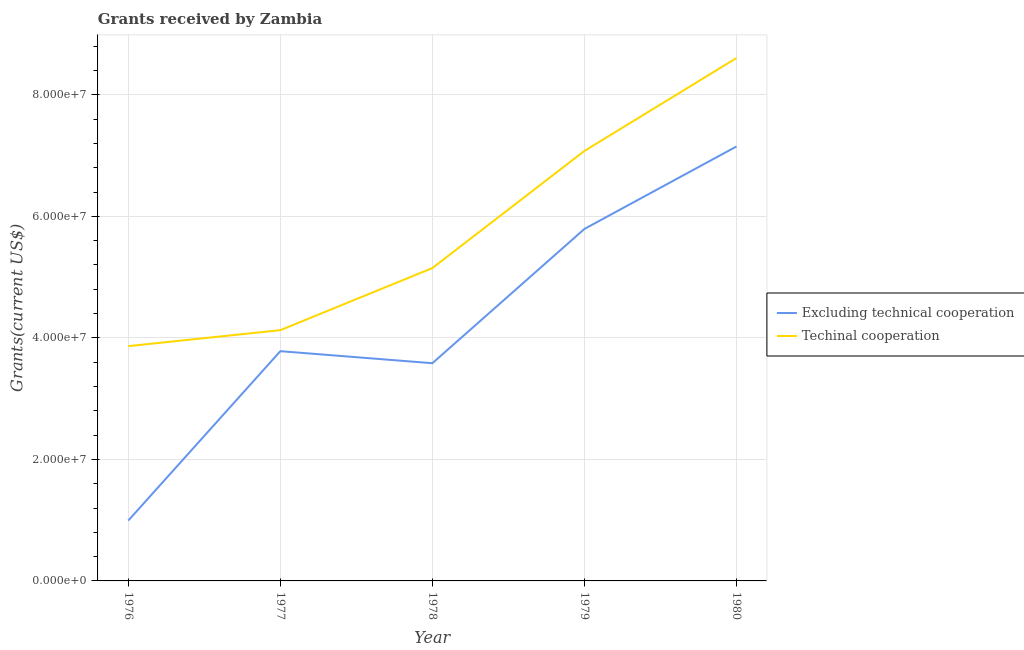Does the line corresponding to amount of grants received(excluding technical cooperation) intersect with the line corresponding to amount of grants received(including technical cooperation)?
Your answer should be very brief. No. What is the amount of grants received(excluding technical cooperation) in 1978?
Keep it short and to the point. 3.58e+07. Across all years, what is the maximum amount of grants received(including technical cooperation)?
Your answer should be compact. 8.61e+07. Across all years, what is the minimum amount of grants received(including technical cooperation)?
Provide a short and direct response. 3.86e+07. In which year was the amount of grants received(including technical cooperation) maximum?
Offer a very short reply. 1980. In which year was the amount of grants received(including technical cooperation) minimum?
Provide a succinct answer. 1976. What is the total amount of grants received(excluding technical cooperation) in the graph?
Your response must be concise. 2.13e+08. What is the difference between the amount of grants received(including technical cooperation) in 1976 and that in 1980?
Make the answer very short. -4.74e+07. What is the difference between the amount of grants received(excluding technical cooperation) in 1979 and the amount of grants received(including technical cooperation) in 1976?
Keep it short and to the point. 1.93e+07. What is the average amount of grants received(including technical cooperation) per year?
Your response must be concise. 5.76e+07. In the year 1979, what is the difference between the amount of grants received(including technical cooperation) and amount of grants received(excluding technical cooperation)?
Offer a terse response. 1.28e+07. In how many years, is the amount of grants received(including technical cooperation) greater than 32000000 US$?
Keep it short and to the point. 5. What is the ratio of the amount of grants received(including technical cooperation) in 1977 to that in 1978?
Offer a very short reply. 0.8. Is the difference between the amount of grants received(excluding technical cooperation) in 1979 and 1980 greater than the difference between the amount of grants received(including technical cooperation) in 1979 and 1980?
Provide a short and direct response. Yes. What is the difference between the highest and the second highest amount of grants received(including technical cooperation)?
Offer a very short reply. 1.53e+07. What is the difference between the highest and the lowest amount of grants received(including technical cooperation)?
Provide a succinct answer. 4.74e+07. Is the amount of grants received(excluding technical cooperation) strictly greater than the amount of grants received(including technical cooperation) over the years?
Ensure brevity in your answer.  No. How many years are there in the graph?
Provide a short and direct response. 5. Are the values on the major ticks of Y-axis written in scientific E-notation?
Ensure brevity in your answer.  Yes. Where does the legend appear in the graph?
Make the answer very short. Center right. What is the title of the graph?
Keep it short and to the point. Grants received by Zambia. Does "Young" appear as one of the legend labels in the graph?
Provide a succinct answer. No. What is the label or title of the X-axis?
Provide a short and direct response. Year. What is the label or title of the Y-axis?
Ensure brevity in your answer.  Grants(current US$). What is the Grants(current US$) in Excluding technical cooperation in 1976?
Offer a very short reply. 9.93e+06. What is the Grants(current US$) in Techinal cooperation in 1976?
Your answer should be compact. 3.86e+07. What is the Grants(current US$) of Excluding technical cooperation in 1977?
Your answer should be compact. 3.78e+07. What is the Grants(current US$) in Techinal cooperation in 1977?
Offer a very short reply. 4.13e+07. What is the Grants(current US$) in Excluding technical cooperation in 1978?
Keep it short and to the point. 3.58e+07. What is the Grants(current US$) of Techinal cooperation in 1978?
Keep it short and to the point. 5.15e+07. What is the Grants(current US$) of Excluding technical cooperation in 1979?
Offer a very short reply. 5.79e+07. What is the Grants(current US$) in Techinal cooperation in 1979?
Offer a very short reply. 7.08e+07. What is the Grants(current US$) in Excluding technical cooperation in 1980?
Offer a terse response. 7.15e+07. What is the Grants(current US$) of Techinal cooperation in 1980?
Offer a terse response. 8.61e+07. Across all years, what is the maximum Grants(current US$) in Excluding technical cooperation?
Offer a very short reply. 7.15e+07. Across all years, what is the maximum Grants(current US$) of Techinal cooperation?
Offer a terse response. 8.61e+07. Across all years, what is the minimum Grants(current US$) of Excluding technical cooperation?
Provide a short and direct response. 9.93e+06. Across all years, what is the minimum Grants(current US$) in Techinal cooperation?
Provide a succinct answer. 3.86e+07. What is the total Grants(current US$) in Excluding technical cooperation in the graph?
Offer a very short reply. 2.13e+08. What is the total Grants(current US$) in Techinal cooperation in the graph?
Your answer should be very brief. 2.88e+08. What is the difference between the Grants(current US$) of Excluding technical cooperation in 1976 and that in 1977?
Your answer should be very brief. -2.79e+07. What is the difference between the Grants(current US$) of Techinal cooperation in 1976 and that in 1977?
Offer a very short reply. -2.63e+06. What is the difference between the Grants(current US$) in Excluding technical cooperation in 1976 and that in 1978?
Make the answer very short. -2.59e+07. What is the difference between the Grants(current US$) in Techinal cooperation in 1976 and that in 1978?
Ensure brevity in your answer.  -1.28e+07. What is the difference between the Grants(current US$) of Excluding technical cooperation in 1976 and that in 1979?
Offer a very short reply. -4.80e+07. What is the difference between the Grants(current US$) of Techinal cooperation in 1976 and that in 1979?
Your answer should be compact. -3.21e+07. What is the difference between the Grants(current US$) of Excluding technical cooperation in 1976 and that in 1980?
Offer a very short reply. -6.16e+07. What is the difference between the Grants(current US$) in Techinal cooperation in 1976 and that in 1980?
Offer a terse response. -4.74e+07. What is the difference between the Grants(current US$) of Excluding technical cooperation in 1977 and that in 1978?
Keep it short and to the point. 1.98e+06. What is the difference between the Grants(current US$) of Techinal cooperation in 1977 and that in 1978?
Make the answer very short. -1.02e+07. What is the difference between the Grants(current US$) of Excluding technical cooperation in 1977 and that in 1979?
Ensure brevity in your answer.  -2.01e+07. What is the difference between the Grants(current US$) of Techinal cooperation in 1977 and that in 1979?
Give a very brief answer. -2.95e+07. What is the difference between the Grants(current US$) in Excluding technical cooperation in 1977 and that in 1980?
Provide a short and direct response. -3.37e+07. What is the difference between the Grants(current US$) of Techinal cooperation in 1977 and that in 1980?
Keep it short and to the point. -4.48e+07. What is the difference between the Grants(current US$) of Excluding technical cooperation in 1978 and that in 1979?
Offer a very short reply. -2.21e+07. What is the difference between the Grants(current US$) of Techinal cooperation in 1978 and that in 1979?
Your answer should be compact. -1.93e+07. What is the difference between the Grants(current US$) in Excluding technical cooperation in 1978 and that in 1980?
Your answer should be compact. -3.57e+07. What is the difference between the Grants(current US$) in Techinal cooperation in 1978 and that in 1980?
Provide a succinct answer. -3.46e+07. What is the difference between the Grants(current US$) of Excluding technical cooperation in 1979 and that in 1980?
Keep it short and to the point. -1.36e+07. What is the difference between the Grants(current US$) in Techinal cooperation in 1979 and that in 1980?
Provide a short and direct response. -1.53e+07. What is the difference between the Grants(current US$) in Excluding technical cooperation in 1976 and the Grants(current US$) in Techinal cooperation in 1977?
Offer a very short reply. -3.13e+07. What is the difference between the Grants(current US$) in Excluding technical cooperation in 1976 and the Grants(current US$) in Techinal cooperation in 1978?
Keep it short and to the point. -4.16e+07. What is the difference between the Grants(current US$) of Excluding technical cooperation in 1976 and the Grants(current US$) of Techinal cooperation in 1979?
Your answer should be compact. -6.08e+07. What is the difference between the Grants(current US$) of Excluding technical cooperation in 1976 and the Grants(current US$) of Techinal cooperation in 1980?
Keep it short and to the point. -7.61e+07. What is the difference between the Grants(current US$) of Excluding technical cooperation in 1977 and the Grants(current US$) of Techinal cooperation in 1978?
Your response must be concise. -1.37e+07. What is the difference between the Grants(current US$) in Excluding technical cooperation in 1977 and the Grants(current US$) in Techinal cooperation in 1979?
Provide a succinct answer. -3.30e+07. What is the difference between the Grants(current US$) of Excluding technical cooperation in 1977 and the Grants(current US$) of Techinal cooperation in 1980?
Make the answer very short. -4.82e+07. What is the difference between the Grants(current US$) of Excluding technical cooperation in 1978 and the Grants(current US$) of Techinal cooperation in 1979?
Offer a terse response. -3.49e+07. What is the difference between the Grants(current US$) in Excluding technical cooperation in 1978 and the Grants(current US$) in Techinal cooperation in 1980?
Provide a succinct answer. -5.02e+07. What is the difference between the Grants(current US$) of Excluding technical cooperation in 1979 and the Grants(current US$) of Techinal cooperation in 1980?
Your response must be concise. -2.81e+07. What is the average Grants(current US$) of Excluding technical cooperation per year?
Your response must be concise. 4.26e+07. What is the average Grants(current US$) in Techinal cooperation per year?
Your response must be concise. 5.76e+07. In the year 1976, what is the difference between the Grants(current US$) of Excluding technical cooperation and Grants(current US$) of Techinal cooperation?
Give a very brief answer. -2.87e+07. In the year 1977, what is the difference between the Grants(current US$) of Excluding technical cooperation and Grants(current US$) of Techinal cooperation?
Your answer should be very brief. -3.46e+06. In the year 1978, what is the difference between the Grants(current US$) of Excluding technical cooperation and Grants(current US$) of Techinal cooperation?
Offer a very short reply. -1.57e+07. In the year 1979, what is the difference between the Grants(current US$) in Excluding technical cooperation and Grants(current US$) in Techinal cooperation?
Your answer should be very brief. -1.28e+07. In the year 1980, what is the difference between the Grants(current US$) of Excluding technical cooperation and Grants(current US$) of Techinal cooperation?
Offer a terse response. -1.46e+07. What is the ratio of the Grants(current US$) in Excluding technical cooperation in 1976 to that in 1977?
Keep it short and to the point. 0.26. What is the ratio of the Grants(current US$) in Techinal cooperation in 1976 to that in 1977?
Your answer should be compact. 0.94. What is the ratio of the Grants(current US$) in Excluding technical cooperation in 1976 to that in 1978?
Offer a very short reply. 0.28. What is the ratio of the Grants(current US$) in Techinal cooperation in 1976 to that in 1978?
Offer a terse response. 0.75. What is the ratio of the Grants(current US$) in Excluding technical cooperation in 1976 to that in 1979?
Make the answer very short. 0.17. What is the ratio of the Grants(current US$) in Techinal cooperation in 1976 to that in 1979?
Your answer should be very brief. 0.55. What is the ratio of the Grants(current US$) in Excluding technical cooperation in 1976 to that in 1980?
Your response must be concise. 0.14. What is the ratio of the Grants(current US$) of Techinal cooperation in 1976 to that in 1980?
Provide a succinct answer. 0.45. What is the ratio of the Grants(current US$) of Excluding technical cooperation in 1977 to that in 1978?
Make the answer very short. 1.06. What is the ratio of the Grants(current US$) in Techinal cooperation in 1977 to that in 1978?
Your answer should be compact. 0.8. What is the ratio of the Grants(current US$) in Excluding technical cooperation in 1977 to that in 1979?
Your response must be concise. 0.65. What is the ratio of the Grants(current US$) of Techinal cooperation in 1977 to that in 1979?
Provide a succinct answer. 0.58. What is the ratio of the Grants(current US$) of Excluding technical cooperation in 1977 to that in 1980?
Provide a short and direct response. 0.53. What is the ratio of the Grants(current US$) of Techinal cooperation in 1977 to that in 1980?
Ensure brevity in your answer.  0.48. What is the ratio of the Grants(current US$) of Excluding technical cooperation in 1978 to that in 1979?
Ensure brevity in your answer.  0.62. What is the ratio of the Grants(current US$) of Techinal cooperation in 1978 to that in 1979?
Give a very brief answer. 0.73. What is the ratio of the Grants(current US$) of Excluding technical cooperation in 1978 to that in 1980?
Keep it short and to the point. 0.5. What is the ratio of the Grants(current US$) of Techinal cooperation in 1978 to that in 1980?
Give a very brief answer. 0.6. What is the ratio of the Grants(current US$) of Excluding technical cooperation in 1979 to that in 1980?
Your answer should be very brief. 0.81. What is the ratio of the Grants(current US$) in Techinal cooperation in 1979 to that in 1980?
Give a very brief answer. 0.82. What is the difference between the highest and the second highest Grants(current US$) of Excluding technical cooperation?
Make the answer very short. 1.36e+07. What is the difference between the highest and the second highest Grants(current US$) in Techinal cooperation?
Provide a succinct answer. 1.53e+07. What is the difference between the highest and the lowest Grants(current US$) of Excluding technical cooperation?
Your answer should be compact. 6.16e+07. What is the difference between the highest and the lowest Grants(current US$) in Techinal cooperation?
Your answer should be compact. 4.74e+07. 